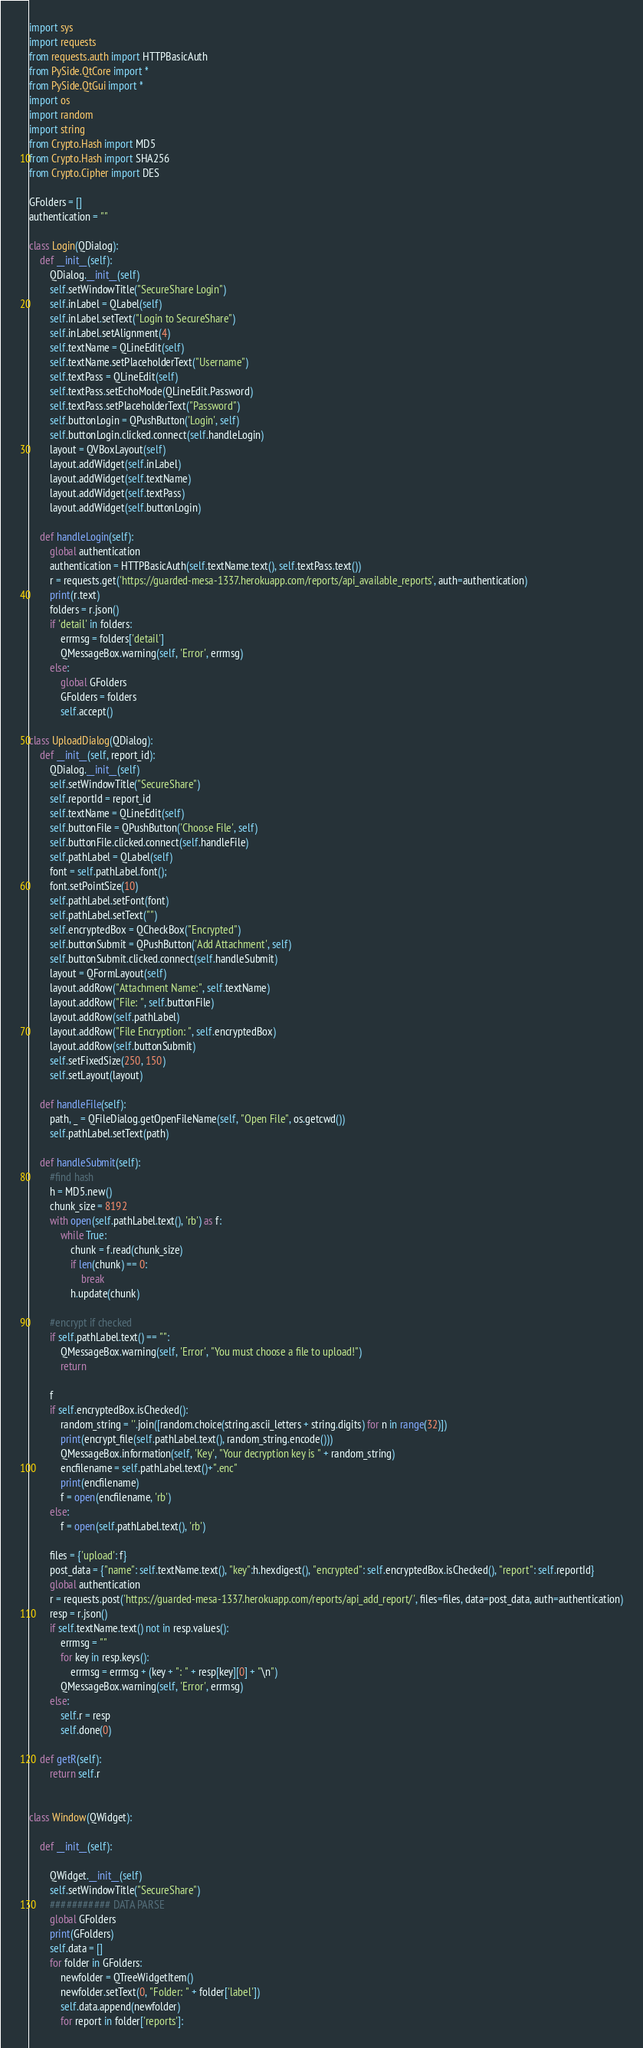<code> <loc_0><loc_0><loc_500><loc_500><_Python_>import sys
import requests
from requests.auth import HTTPBasicAuth
from PySide.QtCore import *
from PySide.QtGui import *
import os
import random
import string
from Crypto.Hash import MD5
from Crypto.Hash import SHA256
from Crypto.Cipher import DES

GFolders = []
authentication = ""

class Login(QDialog):
    def __init__(self):
        QDialog.__init__(self)
        self.setWindowTitle("SecureShare Login")
        self.inLabel = QLabel(self)
        self.inLabel.setText("Login to SecureShare")
        self.inLabel.setAlignment(4)
        self.textName = QLineEdit(self)
        self.textName.setPlaceholderText("Username")
        self.textPass = QLineEdit(self)
        self.textPass.setEchoMode(QLineEdit.Password)
        self.textPass.setPlaceholderText("Password")
        self.buttonLogin = QPushButton('Login', self)
        self.buttonLogin.clicked.connect(self.handleLogin)
        layout = QVBoxLayout(self)
        layout.addWidget(self.inLabel)
        layout.addWidget(self.textName)
        layout.addWidget(self.textPass)
        layout.addWidget(self.buttonLogin)

    def handleLogin(self):
        global authentication
        authentication = HTTPBasicAuth(self.textName.text(), self.textPass.text())
        r = requests.get('https://guarded-mesa-1337.herokuapp.com/reports/api_available_reports', auth=authentication)
        print(r.text)
        folders = r.json()
        if 'detail' in folders:
            errmsg = folders['detail']
            QMessageBox.warning(self, 'Error', errmsg)
        else:
            global GFolders
            GFolders = folders
            self.accept()

class UploadDialog(QDialog):
    def __init__(self, report_id):
        QDialog.__init__(self)
        self.setWindowTitle("SecureShare")
        self.reportId = report_id
        self.textName = QLineEdit(self)
        self.buttonFile = QPushButton('Choose File', self)
        self.buttonFile.clicked.connect(self.handleFile)
        self.pathLabel = QLabel(self)
        font = self.pathLabel.font();
        font.setPointSize(10)
        self.pathLabel.setFont(font)
        self.pathLabel.setText("")
        self.encryptedBox = QCheckBox("Encrypted")
        self.buttonSubmit = QPushButton('Add Attachment', self)
        self.buttonSubmit.clicked.connect(self.handleSubmit)
        layout = QFormLayout(self)
        layout.addRow("Attachment Name:", self.textName)
        layout.addRow("File: ", self.buttonFile)
        layout.addRow(self.pathLabel)
        layout.addRow("File Encryption: ", self.encryptedBox)
        layout.addRow(self.buttonSubmit)
        self.setFixedSize(250, 150)
        self.setLayout(layout)

    def handleFile(self):
        path, _ = QFileDialog.getOpenFileName(self, "Open File", os.getcwd())
        self.pathLabel.setText(path)

    def handleSubmit(self):
        #find hash
        h = MD5.new()
        chunk_size = 8192
        with open(self.pathLabel.text(), 'rb') as f:
            while True:
                chunk = f.read(chunk_size)
                if len(chunk) == 0:
                    break
                h.update(chunk)

        #encrypt if checked
        if self.pathLabel.text() == "":
            QMessageBox.warning(self, 'Error', "You must choose a file to upload!")
            return

        f
        if self.encryptedBox.isChecked():
            random_string = ''.join([random.choice(string.ascii_letters + string.digits) for n in range(32)])
            print(encrypt_file(self.pathLabel.text(), random_string.encode()))
            QMessageBox.information(self, 'Key', "Your decryption key is " + random_string)
            encfilename = self.pathLabel.text()+".enc"
            print(encfilename)
            f = open(encfilename, 'rb')
        else:
            f = open(self.pathLabel.text(), 'rb')

        files = {'upload': f}
        post_data = {"name": self.textName.text(), "key":h.hexdigest(), "encrypted": self.encryptedBox.isChecked(), "report": self.reportId}
        global authentication
        r = requests.post('https://guarded-mesa-1337.herokuapp.com/reports/api_add_report/', files=files, data=post_data, auth=authentication)
        resp = r.json()
        if self.textName.text() not in resp.values():
            errmsg = ""
            for key in resp.keys():
                errmsg = errmsg + (key + ": " + resp[key][0] + "\n")
            QMessageBox.warning(self, 'Error', errmsg)
        else:
            self.r = resp
            self.done(0)

    def getR(self):
        return self.r


class Window(QWidget):

    def __init__(self):

        QWidget.__init__(self)
        self.setWindowTitle("SecureShare")
        ########### DATA PARSE
        global GFolders
        print(GFolders)
        self.data = []
        for folder in GFolders:
            newfolder = QTreeWidgetItem()
            newfolder.setText(0, "Folder: " + folder['label'])
            self.data.append(newfolder)
            for report in folder['reports']:</code> 